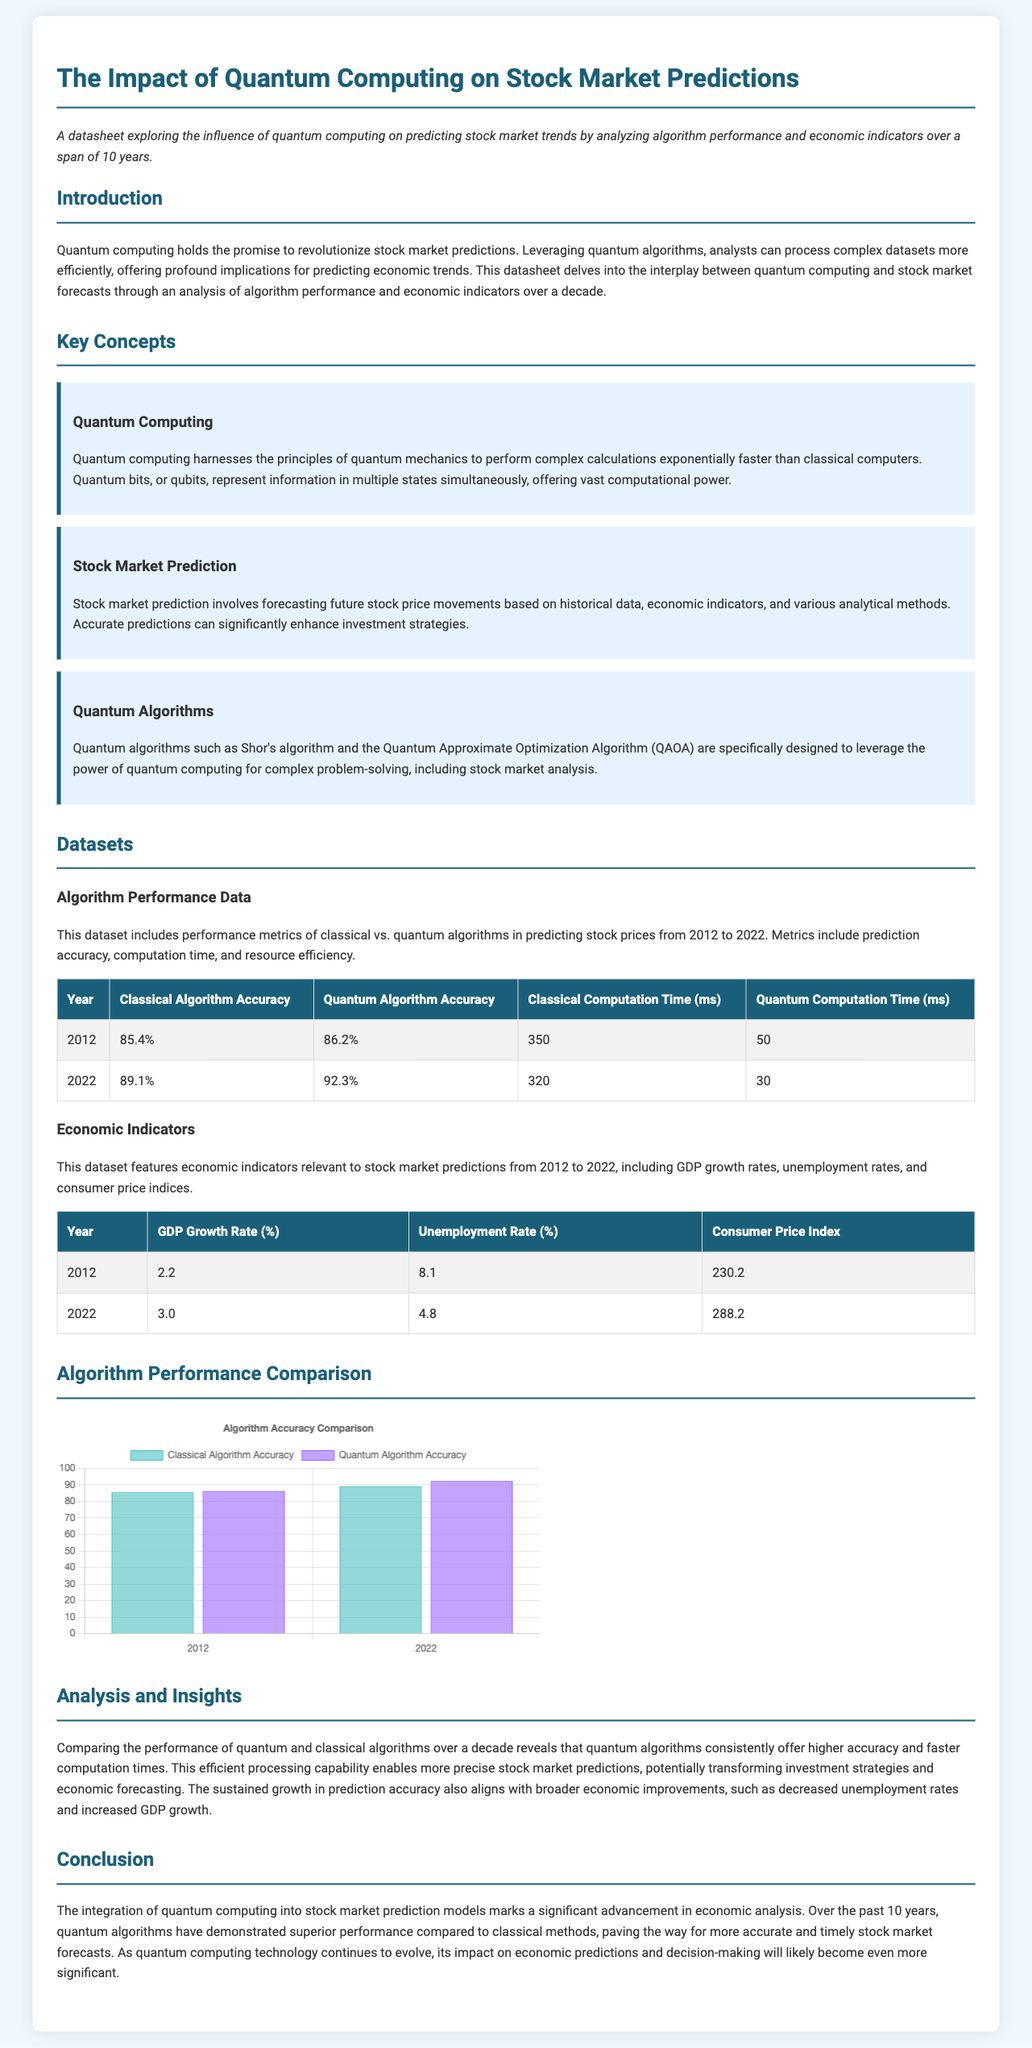What is the title of the document? The title of the document is presented at the top of the datasheet.
Answer: The Impact of Quantum Computing on Stock Market Predictions What years does the algorithm performance data cover? The dataset includes performance metrics from 2012 to 2022.
Answer: 2012 to 2022 What is the accuracy of quantum algorithms in 2022? The accuracy is reported in the dataset under the 'Quantum Algorithm Accuracy' column for 2022.
Answer: 92.3% What was the GDP growth rate in 2012? The GDP growth rate is detailed in the economic indicators table for that year.
Answer: 2.2 Which algorithm showed higher accuracy in 2012? The comparison is made in the algorithm performance section, highlighting the accuracies of both algorithms.
Answer: Quantum Algorithm How does the unemployment rate change from 2012 to 2022? The change can be inferred by comparing the unemployment rates from the economic indicators table across the years.
Answer: Decreased What is the conclusion drawn about quantum algorithms? The conclusion summarizes the key findings related to algorithm performance and economic implications.
Answer: Superior performance compared to classical methods What is the predicted impact of quantum computing on economic predictions? The document offers insights into the future implications of quantum computing on economic forecasting.
Answer: Significant impact 